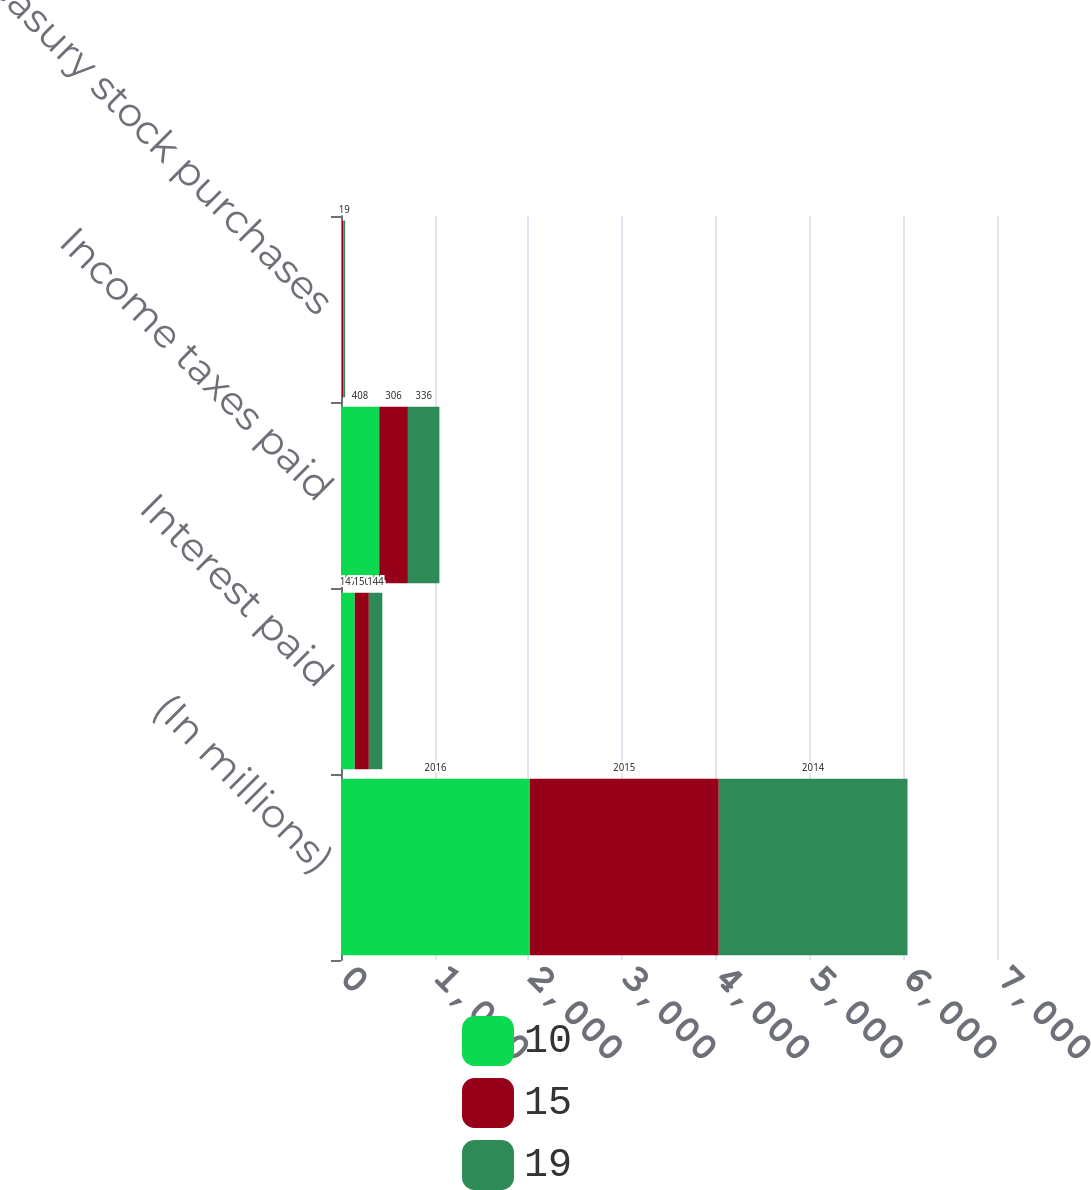Convert chart. <chart><loc_0><loc_0><loc_500><loc_500><stacked_bar_chart><ecel><fcel>(In millions)<fcel>Interest paid<fcel>Income taxes paid<fcel>Treasury stock purchases<nl><fcel>10<fcel>2016<fcel>147<fcel>408<fcel>10<nl><fcel>15<fcel>2015<fcel>150<fcel>306<fcel>15<nl><fcel>19<fcel>2014<fcel>144<fcel>336<fcel>19<nl></chart> 